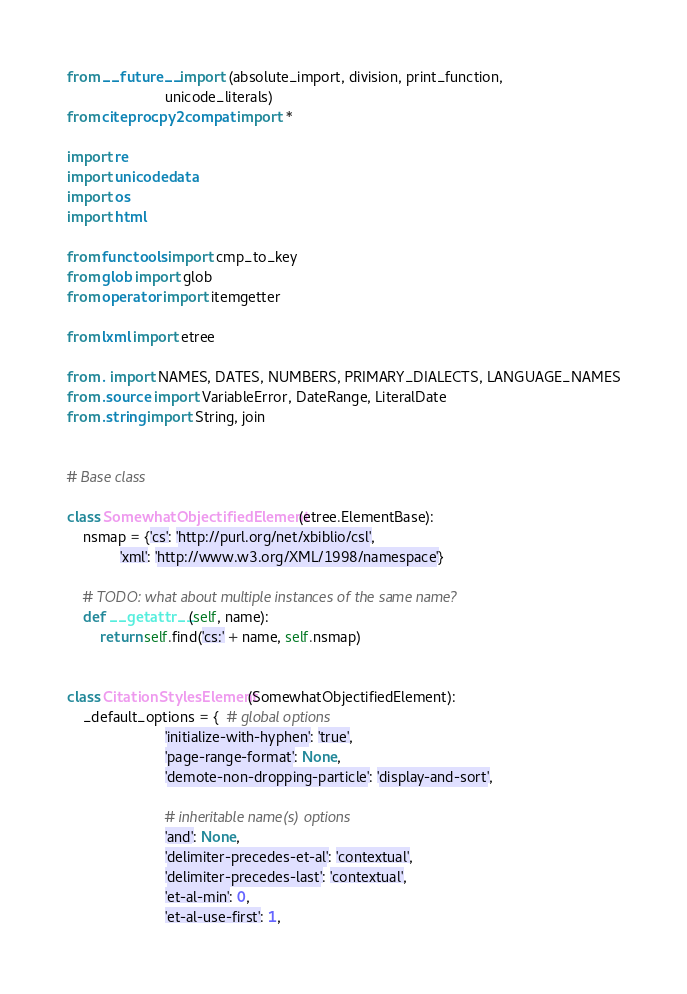<code> <loc_0><loc_0><loc_500><loc_500><_Python_>from __future__ import (absolute_import, division, print_function,
                        unicode_literals)
from citeproc.py2compat import *

import re
import unicodedata
import os
import html

from functools import cmp_to_key
from glob import glob
from operator import itemgetter

from lxml import etree

from . import NAMES, DATES, NUMBERS, PRIMARY_DIALECTS, LANGUAGE_NAMES
from .source import VariableError, DateRange, LiteralDate
from .string import String, join


# Base class

class SomewhatObjectifiedElement(etree.ElementBase):
    nsmap = {'cs': 'http://purl.org/net/xbiblio/csl',
             'xml': 'http://www.w3.org/XML/1998/namespace'}

    # TODO: what about multiple instances of the same name?
    def __getattr__(self, name):
        return self.find('cs:' + name, self.nsmap)


class CitationStylesElement(SomewhatObjectifiedElement):
    _default_options = {  # global options
                        'initialize-with-hyphen': 'true',
                        'page-range-format': None,
                        'demote-non-dropping-particle': 'display-and-sort',

                        # inheritable name(s) options
                        'and': None,
                        'delimiter-precedes-et-al': 'contextual',
                        'delimiter-precedes-last': 'contextual',
                        'et-al-min': 0,
                        'et-al-use-first': 1,</code> 